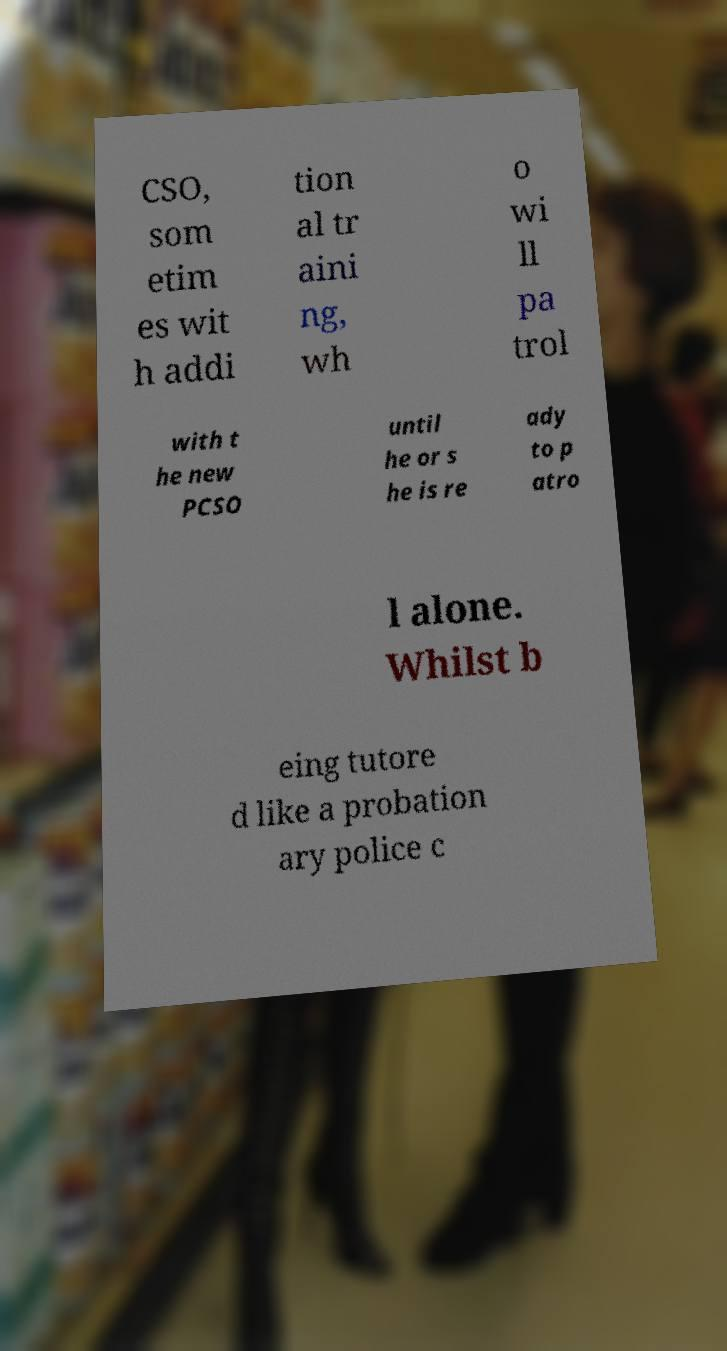There's text embedded in this image that I need extracted. Can you transcribe it verbatim? CSO, som etim es wit h addi tion al tr aini ng, wh o wi ll pa trol with t he new PCSO until he or s he is re ady to p atro l alone. Whilst b eing tutore d like a probation ary police c 